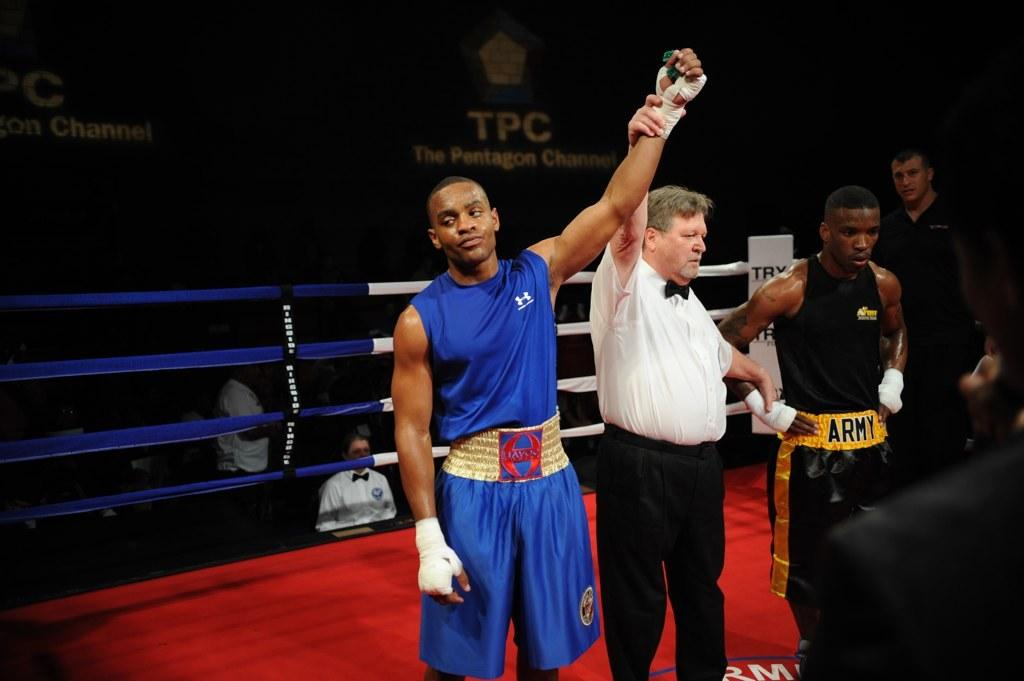<image>
Describe the image concisely. A man wearing a bowtie stands between a man wearing a blue shirt and a man wearing an Army belt. 